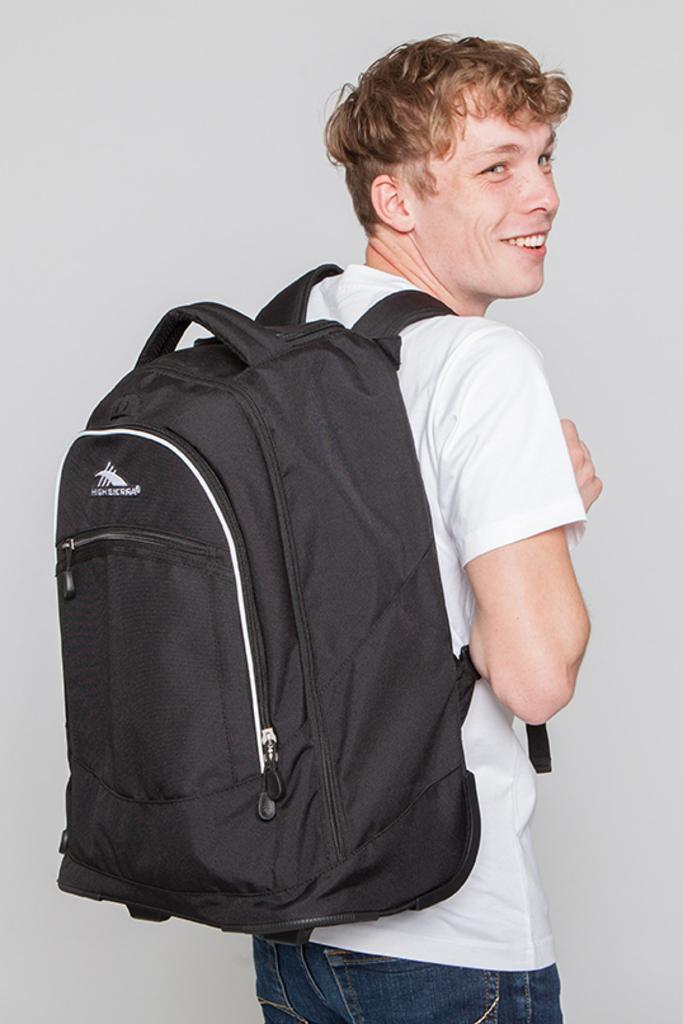Could you give a brief overview of what you see in this image? In the middle of the image a man is standing and smiling and he wears a backpack. 